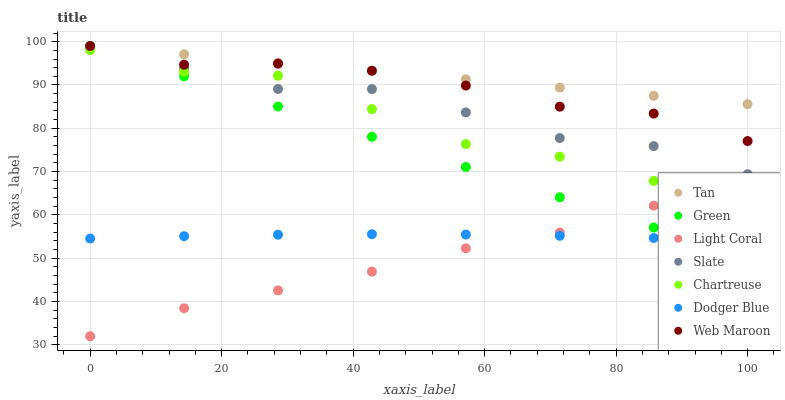Does Light Coral have the minimum area under the curve?
Answer yes or no. Yes. Does Tan have the maximum area under the curve?
Answer yes or no. Yes. Does Web Maroon have the minimum area under the curve?
Answer yes or no. No. Does Web Maroon have the maximum area under the curve?
Answer yes or no. No. Is Tan the smoothest?
Answer yes or no. Yes. Is Chartreuse the roughest?
Answer yes or no. Yes. Is Web Maroon the smoothest?
Answer yes or no. No. Is Web Maroon the roughest?
Answer yes or no. No. Does Light Coral have the lowest value?
Answer yes or no. Yes. Does Web Maroon have the lowest value?
Answer yes or no. No. Does Tan have the highest value?
Answer yes or no. Yes. Does Light Coral have the highest value?
Answer yes or no. No. Is Dodger Blue less than Slate?
Answer yes or no. Yes. Is Web Maroon greater than Chartreuse?
Answer yes or no. Yes. Does Light Coral intersect Green?
Answer yes or no. Yes. Is Light Coral less than Green?
Answer yes or no. No. Is Light Coral greater than Green?
Answer yes or no. No. Does Dodger Blue intersect Slate?
Answer yes or no. No. 